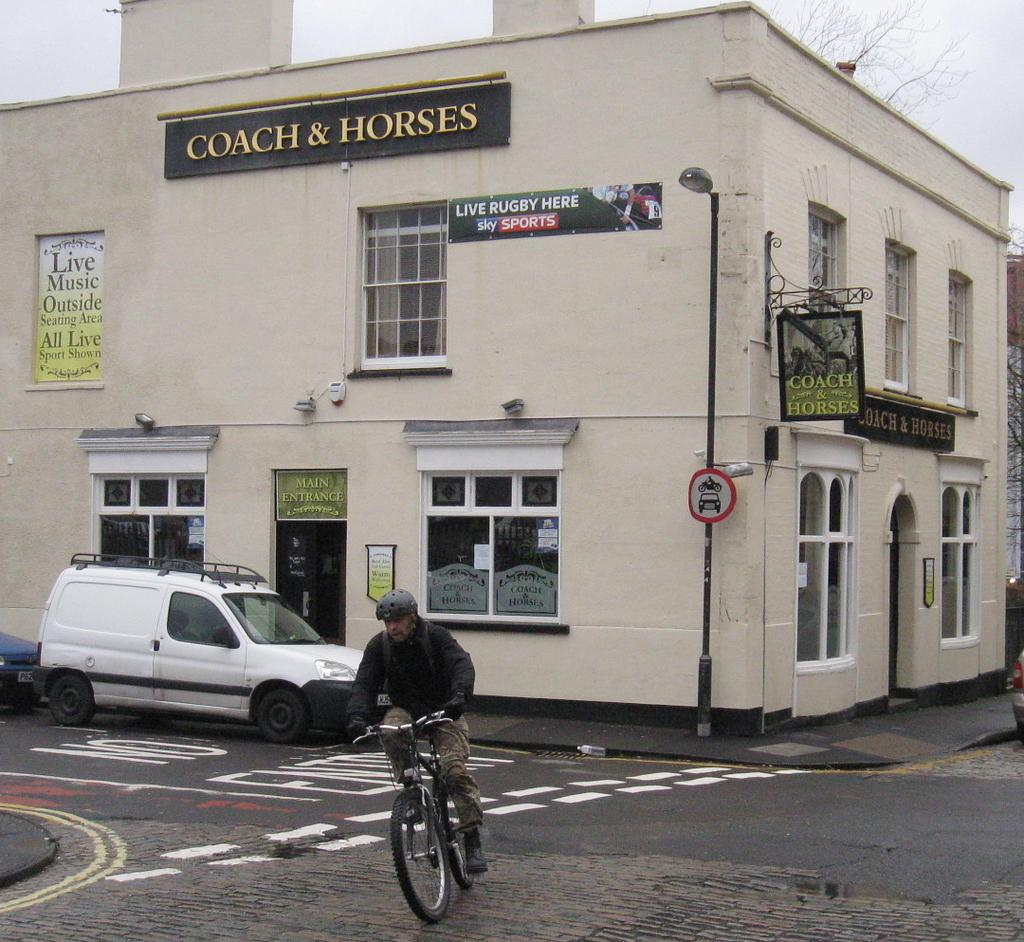What is the man in the image doing? The man is riding a cycle in the image. What can be seen in the background of the image? There is a building, a banner, a sign board, vehicles, and a road in the background of the image. What is the name of the building in the background? The building in the background is named "Coach & Horses". What rhythm is the man on the cycle tapping out with his feet in the image? There is no indication in the image that the man is tapping out a rhythm with his feet while riding the cycle. 